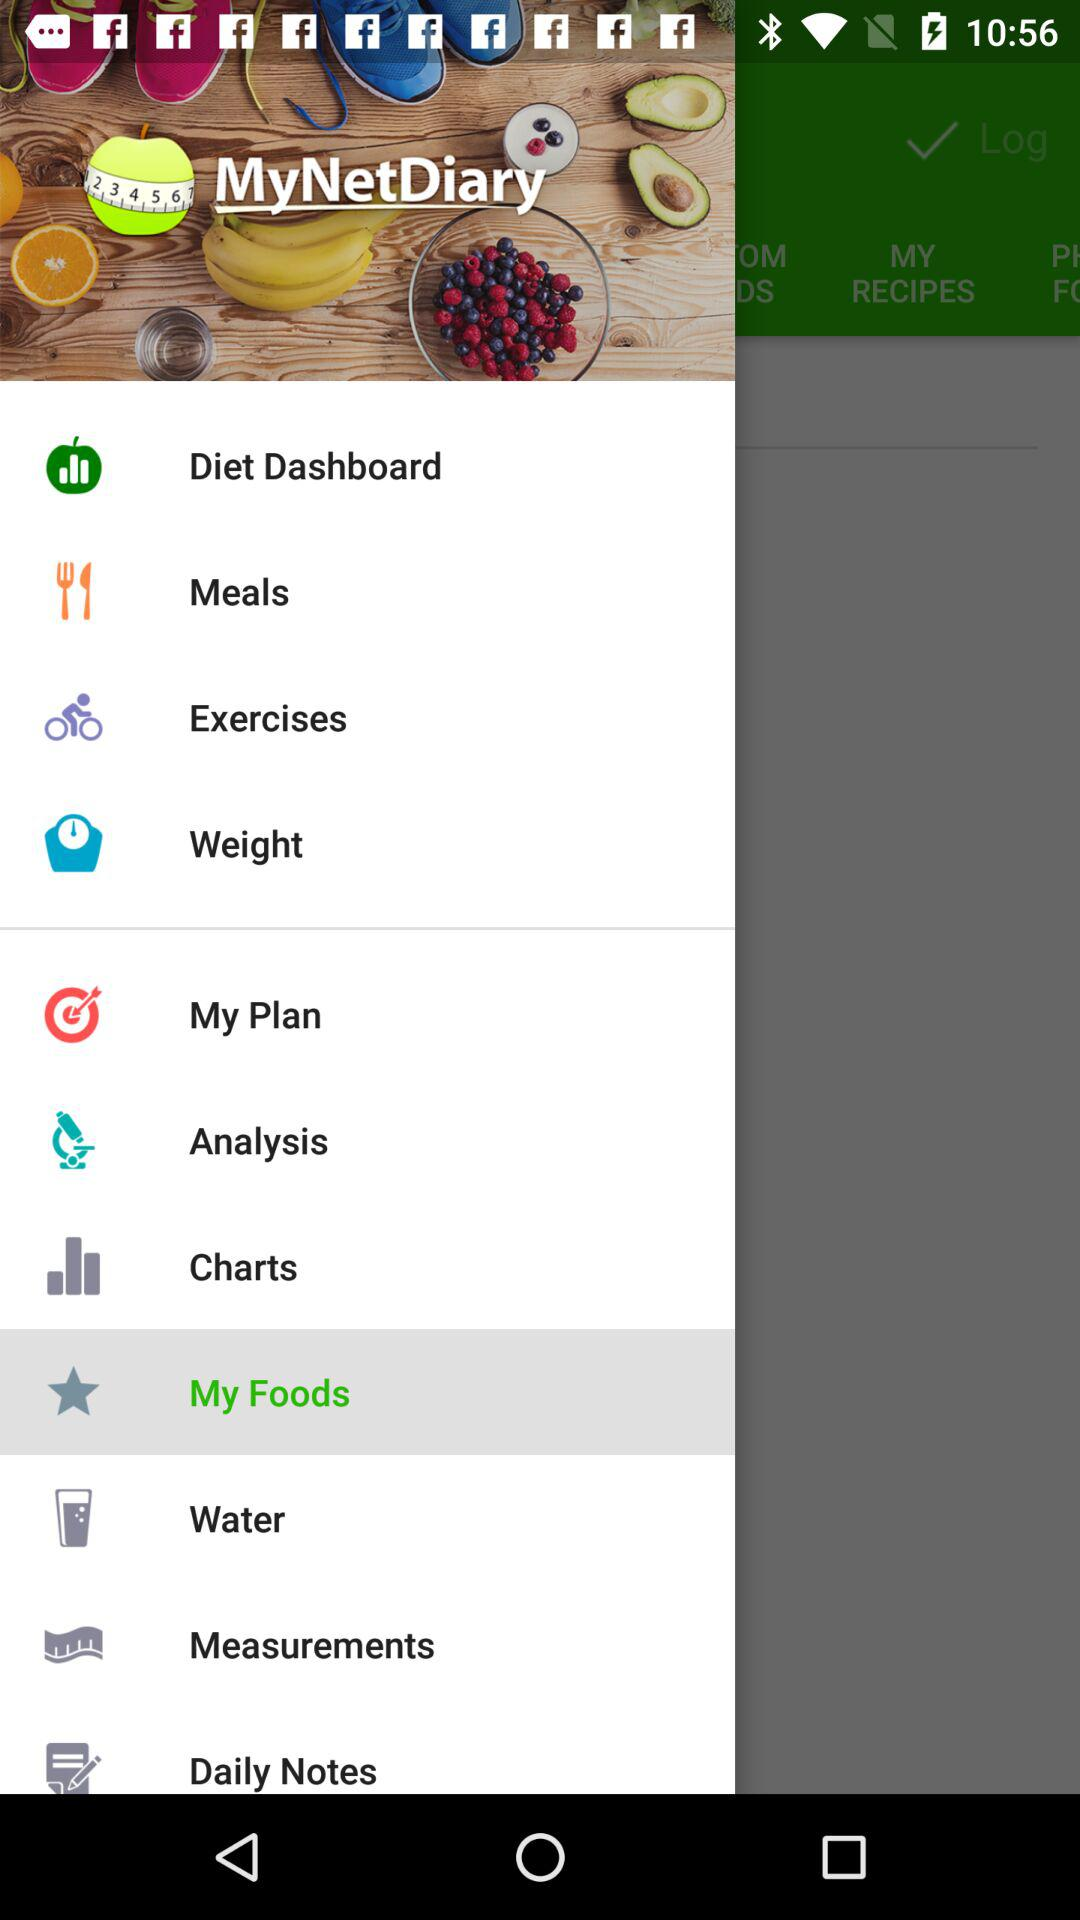What is the name of the application? The name of the application is "MyNetDiary". 